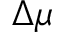Convert formula to latex. <formula><loc_0><loc_0><loc_500><loc_500>\Delta \mu</formula> 